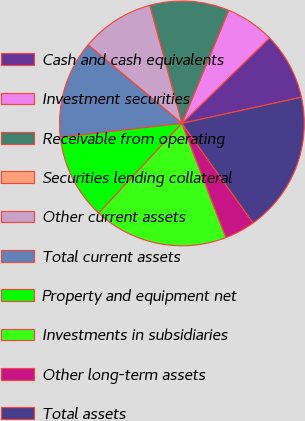<chart> <loc_0><loc_0><loc_500><loc_500><pie_chart><fcel>Cash and cash equivalents<fcel>Investment securities<fcel>Receivable from operating<fcel>Securities lending collateral<fcel>Other current assets<fcel>Total current assets<fcel>Property and equipment net<fcel>Investments in subsidiaries<fcel>Other long-term assets<fcel>Total assets<nl><fcel>8.87%<fcel>6.45%<fcel>10.48%<fcel>0.0%<fcel>9.68%<fcel>12.9%<fcel>11.29%<fcel>17.74%<fcel>4.03%<fcel>18.55%<nl></chart> 